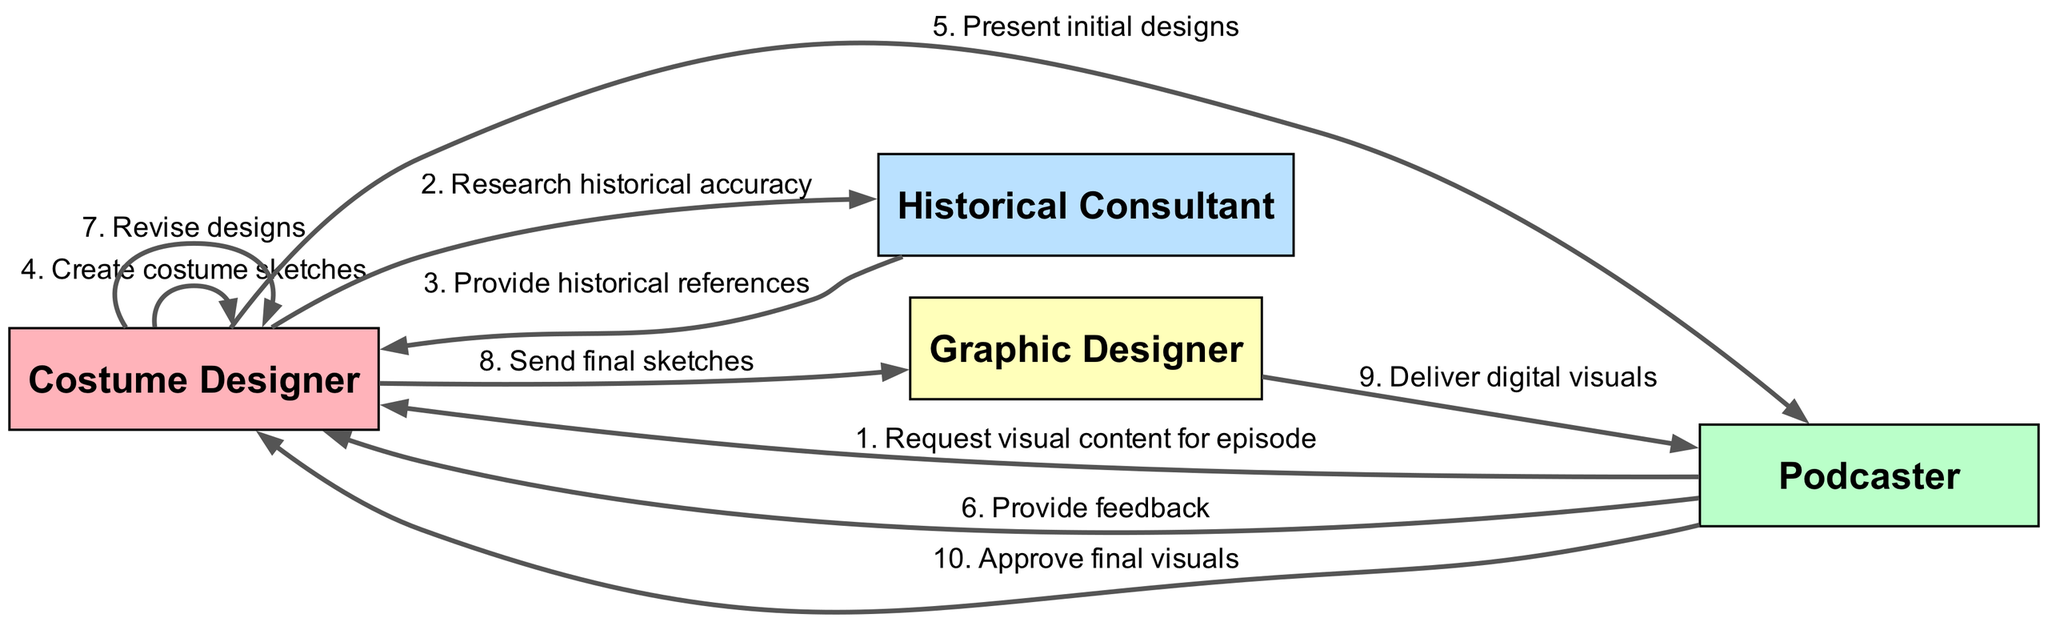What is the first message sent in the sequence? The first message in the sequence is sent from the Podcaster to the Costume Designer, requesting visual content for an episode. Thus, the answer is based on the sequence flow starting from the Podcaster.
Answer: Request visual content for episode How many actors are involved in the workflow? The diagram lists four distinct actors: Costume Designer, Podcaster, Historical Consultant, and Graphic Designer. Counting these actors gives the answer.
Answer: 4 Who provides historical references to the Costume Designer? In the diagram, the Historical Consultant is the one who provides historical references to the Costume Designer, as indicated in the sequence of messages.
Answer: Historical Consultant What is the last action taken before the Podcaster approves the final visuals? The last action before the Podcaster approves the visuals is the Graphic Designer delivering the digital visuals, which is depicted as a direct flow from the Graphic Designer to the Podcaster.
Answer: Deliver digital visuals What type of action does the Costume Designer take after presenting initial designs? After presenting the initial designs, the Costume Designer receives feedback from the Podcaster and subsequently revises the designs. This pattern shows that revising is a follow-up action.
Answer: Revise designs Which actor is responsible for creating the costume sketches? The action of creating costume sketches is performed by the Costume Designer according to the diagram flow, specifically indicated as a self-message for the Costume Designer.
Answer: Costume Designer How many messages are sent from the Costume Designer? The Costume Designer sends a total of four unique messages throughout the workflow: requesting research, presenting designs, revising designs, and sending final sketches. Counting these gives the total number.
Answer: 4 What action does the Podcaster take after receiving feedback from the Costume Designer? The Podcaster provides feedback to the Costume Designer after receiving the initial designs, and thereafter the Costume Designer revises those designs, indicating that the flow of actions continues in this way.
Answer: Provide feedback What is the primary function of the Historical Consultant in this workflow? The primary function of the Historical Consultant is to ensure historical accuracy by providing references to the Costume Designer, as indicated in the sequence.
Answer: Research historical accuracy 